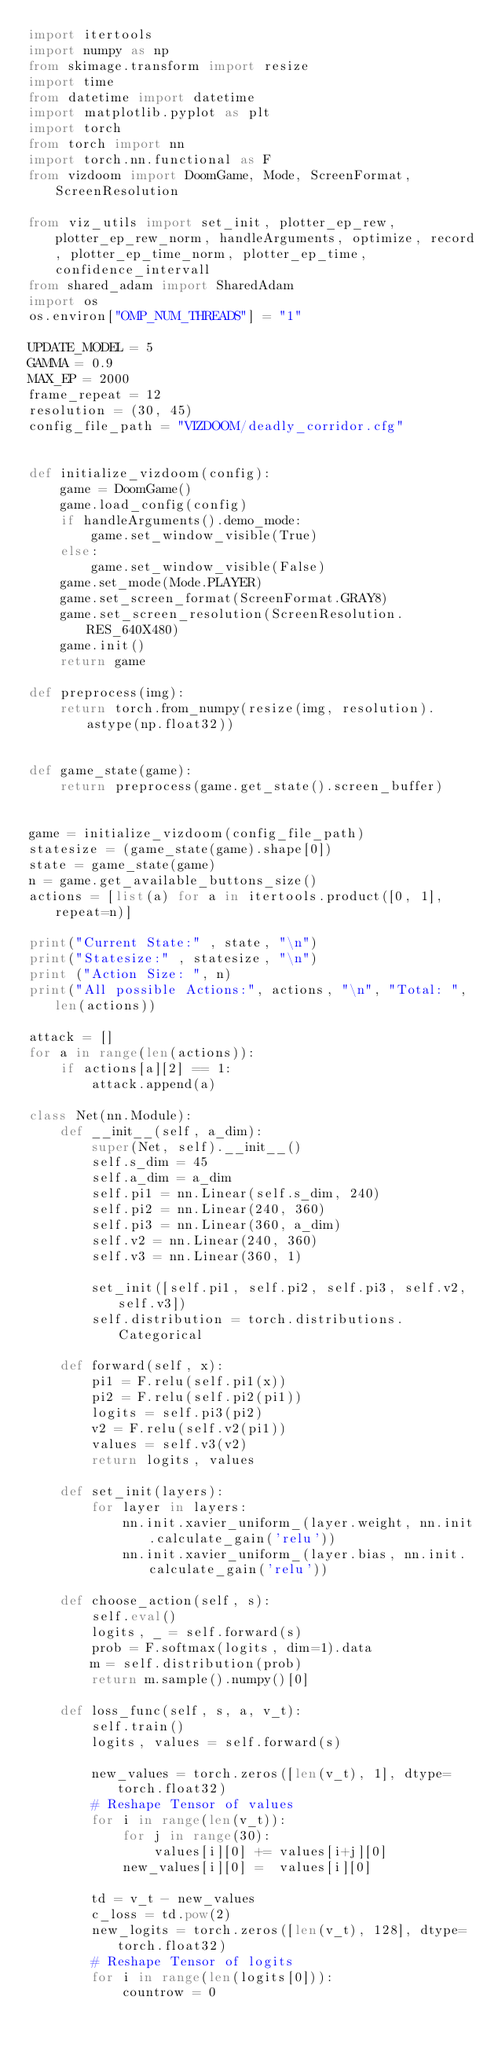<code> <loc_0><loc_0><loc_500><loc_500><_Python_>import itertools
import numpy as np
from skimage.transform import resize
import time
from datetime import datetime
import matplotlib.pyplot as plt
import torch
from torch import nn
import torch.nn.functional as F
from vizdoom import DoomGame, Mode, ScreenFormat, ScreenResolution

from viz_utils import set_init, plotter_ep_rew, plotter_ep_rew_norm, handleArguments, optimize, record, plotter_ep_time_norm, plotter_ep_time, confidence_intervall
from shared_adam import SharedAdam
import os
os.environ["OMP_NUM_THREADS"] = "1"

UPDATE_MODEL = 5
GAMMA = 0.9
MAX_EP = 2000
frame_repeat = 12
resolution = (30, 45)
config_file_path = "VIZDOOM/deadly_corridor.cfg"


def initialize_vizdoom(config):
    game = DoomGame()
    game.load_config(config)
    if handleArguments().demo_mode:
        game.set_window_visible(True)
    else:
        game.set_window_visible(False)
    game.set_mode(Mode.PLAYER)
    game.set_screen_format(ScreenFormat.GRAY8)
    game.set_screen_resolution(ScreenResolution.RES_640X480)
    game.init()
    return game

def preprocess(img):
    return torch.from_numpy(resize(img, resolution).astype(np.float32))


def game_state(game):
    return preprocess(game.get_state().screen_buffer)


game = initialize_vizdoom(config_file_path)
statesize = (game_state(game).shape[0])
state = game_state(game)
n = game.get_available_buttons_size()
actions = [list(a) for a in itertools.product([0, 1], repeat=n)]

print("Current State:" , state, "\n")
print("Statesize:" , statesize, "\n")
print ("Action Size: ", n)
print("All possible Actions:", actions, "\n", "Total: ", len(actions))

attack = []
for a in range(len(actions)):
    if actions[a][2] == 1:
        attack.append(a)

class Net(nn.Module):
    def __init__(self, a_dim):
        super(Net, self).__init__()
        self.s_dim = 45
        self.a_dim = a_dim
        self.pi1 = nn.Linear(self.s_dim, 240)
        self.pi2 = nn.Linear(240, 360)
        self.pi3 = nn.Linear(360, a_dim)
        self.v2 = nn.Linear(240, 360)
        self.v3 = nn.Linear(360, 1)

        set_init([self.pi1, self.pi2, self.pi3, self.v2, self.v3])
        self.distribution = torch.distributions.Categorical

    def forward(self, x):
        pi1 = F.relu(self.pi1(x))
        pi2 = F.relu(self.pi2(pi1))
        logits = self.pi3(pi2)
        v2 = F.relu(self.v2(pi1))
        values = self.v3(v2)
        return logits, values

    def set_init(layers):
        for layer in layers:
            nn.init.xavier_uniform_(layer.weight, nn.init.calculate_gain('relu'))
            nn.init.xavier_uniform_(layer.bias, nn.init.calculate_gain('relu'))

    def choose_action(self, s):
        self.eval()
        logits, _ = self.forward(s)
        prob = F.softmax(logits, dim=1).data
        m = self.distribution(prob)
        return m.sample().numpy()[0]

    def loss_func(self, s, a, v_t):
        self.train()
        logits, values = self.forward(s)

        new_values = torch.zeros([len(v_t), 1], dtype=torch.float32)
        # Reshape Tensor of values
        for i in range(len(v_t)):
            for j in range(30):
                values[i][0] += values[i+j][0]
            new_values[i][0] =  values[i][0]

        td = v_t - new_values
        c_loss = td.pow(2)
        new_logits = torch.zeros([len(v_t), 128], dtype=torch.float32)
        # Reshape Tensor of logits
        for i in range(len(logits[0])):
            countrow = 0</code> 